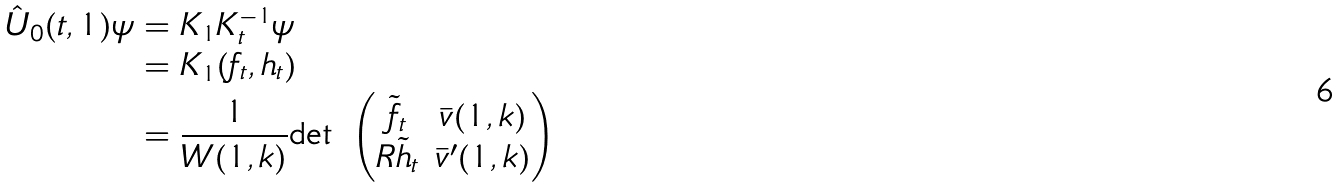<formula> <loc_0><loc_0><loc_500><loc_500>\hat { U } _ { 0 } ( t , 1 ) \psi & = K _ { 1 } K _ { t } ^ { - 1 } \psi \\ & = K _ { 1 } ( f _ { t } , h _ { t } ) \\ & = \frac { 1 } { W ( 1 , k ) } \text {det } \begin{pmatrix} \tilde { f } _ { t } & \bar { v } ( 1 , k ) \\ R \tilde { h } _ { t } & \bar { v } ^ { \prime } ( 1 , k ) \end{pmatrix}</formula> 